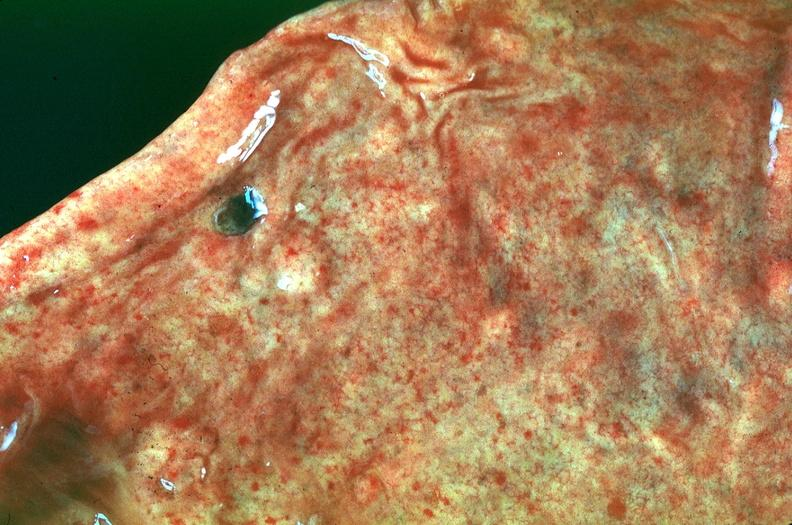how many antitrypsin does this image show stomach, petechial hemorrhages in a patient with disseminated intravascular coagulation and alpha-deficiency?
Answer the question using a single word or phrase. 1 